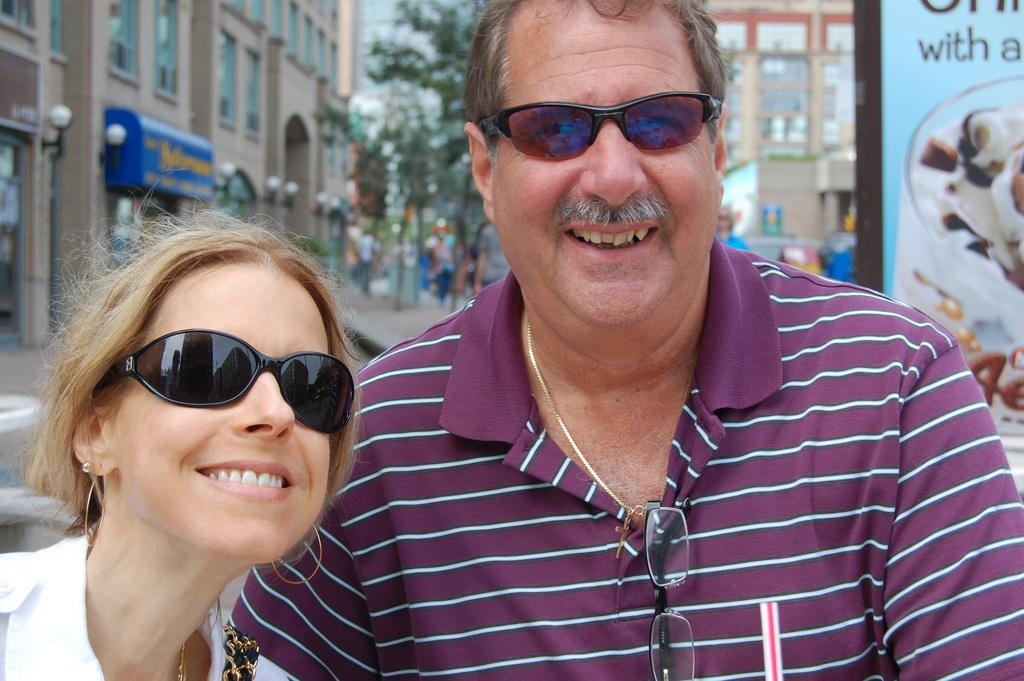How many people are present in the image? There are two people, a man and a woman, present in the image. What are the man and woman wearing on their faces? The man and woman are wearing goggles. What can be seen in the background of the image? There are trees, buildings, and a hoarding in the background of the image. How is the background of the image depicted? The background of the image is blurred. What type of grape is the man holding in the image? There is no grape present in the image; the man and woman are wearing goggles, and there is no mention of any fruit. How much money is the woman holding in the image? There is no money visible in the image; the man and woman are wearing goggles, and there is no mention of any currency. 